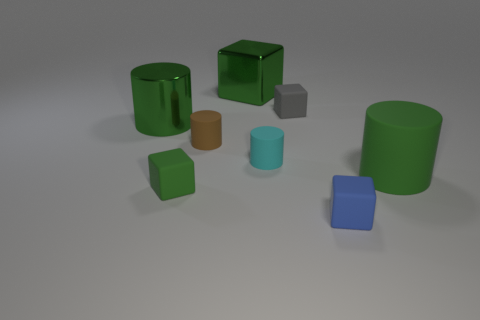Subtract all red cylinders. Subtract all gray balls. How many cylinders are left? 4 Add 2 cyan cylinders. How many objects exist? 10 Add 8 tiny cyan shiny objects. How many tiny cyan shiny objects exist? 8 Subtract 0 red blocks. How many objects are left? 8 Subtract all small cyan rubber objects. Subtract all brown rubber cylinders. How many objects are left? 6 Add 2 big metallic cubes. How many big metallic cubes are left? 3 